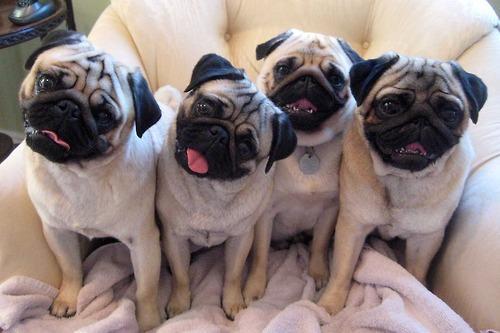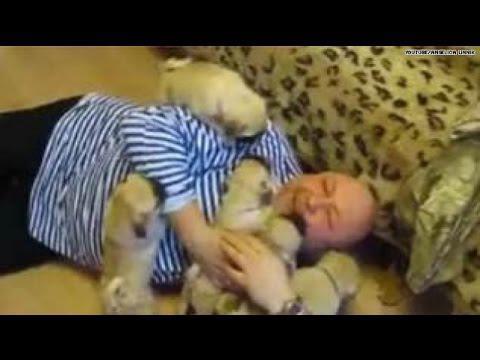The first image is the image on the left, the second image is the image on the right. Considering the images on both sides, is "A human is playing with puppies on the floor" valid? Answer yes or no. Yes. The first image is the image on the left, the second image is the image on the right. Assess this claim about the two images: "A man in a blue and white striped shirt is nuzzling puppies.". Correct or not? Answer yes or no. Yes. 